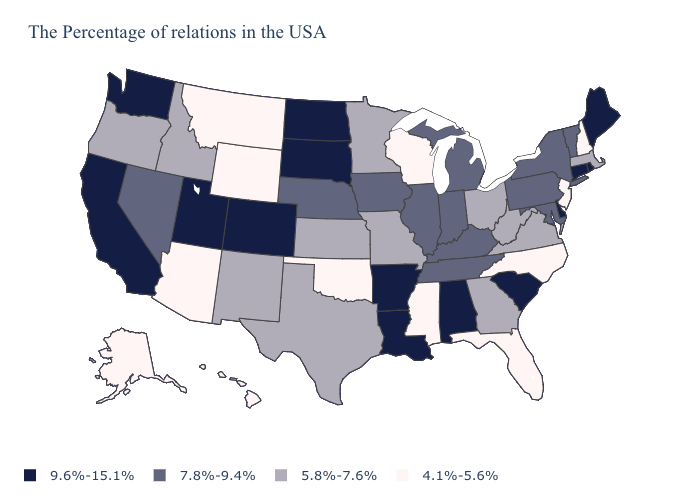Name the states that have a value in the range 7.8%-9.4%?
Short answer required. Vermont, New York, Maryland, Pennsylvania, Michigan, Kentucky, Indiana, Tennessee, Illinois, Iowa, Nebraska, Nevada. What is the lowest value in the USA?
Concise answer only. 4.1%-5.6%. Does Washington have the lowest value in the West?
Short answer required. No. Does Idaho have the same value as Ohio?
Keep it brief. Yes. Name the states that have a value in the range 4.1%-5.6%?
Write a very short answer. New Hampshire, New Jersey, North Carolina, Florida, Wisconsin, Mississippi, Oklahoma, Wyoming, Montana, Arizona, Alaska, Hawaii. How many symbols are there in the legend?
Quick response, please. 4. How many symbols are there in the legend?
Give a very brief answer. 4. What is the highest value in the South ?
Be succinct. 9.6%-15.1%. Which states have the lowest value in the USA?
Keep it brief. New Hampshire, New Jersey, North Carolina, Florida, Wisconsin, Mississippi, Oklahoma, Wyoming, Montana, Arizona, Alaska, Hawaii. What is the value of Hawaii?
Concise answer only. 4.1%-5.6%. Name the states that have a value in the range 9.6%-15.1%?
Be succinct. Maine, Rhode Island, Connecticut, Delaware, South Carolina, Alabama, Louisiana, Arkansas, South Dakota, North Dakota, Colorado, Utah, California, Washington. What is the highest value in the MidWest ?
Short answer required. 9.6%-15.1%. Does Colorado have the same value as Connecticut?
Be succinct. Yes. What is the highest value in states that border Mississippi?
Write a very short answer. 9.6%-15.1%. What is the highest value in states that border New York?
Quick response, please. 9.6%-15.1%. 